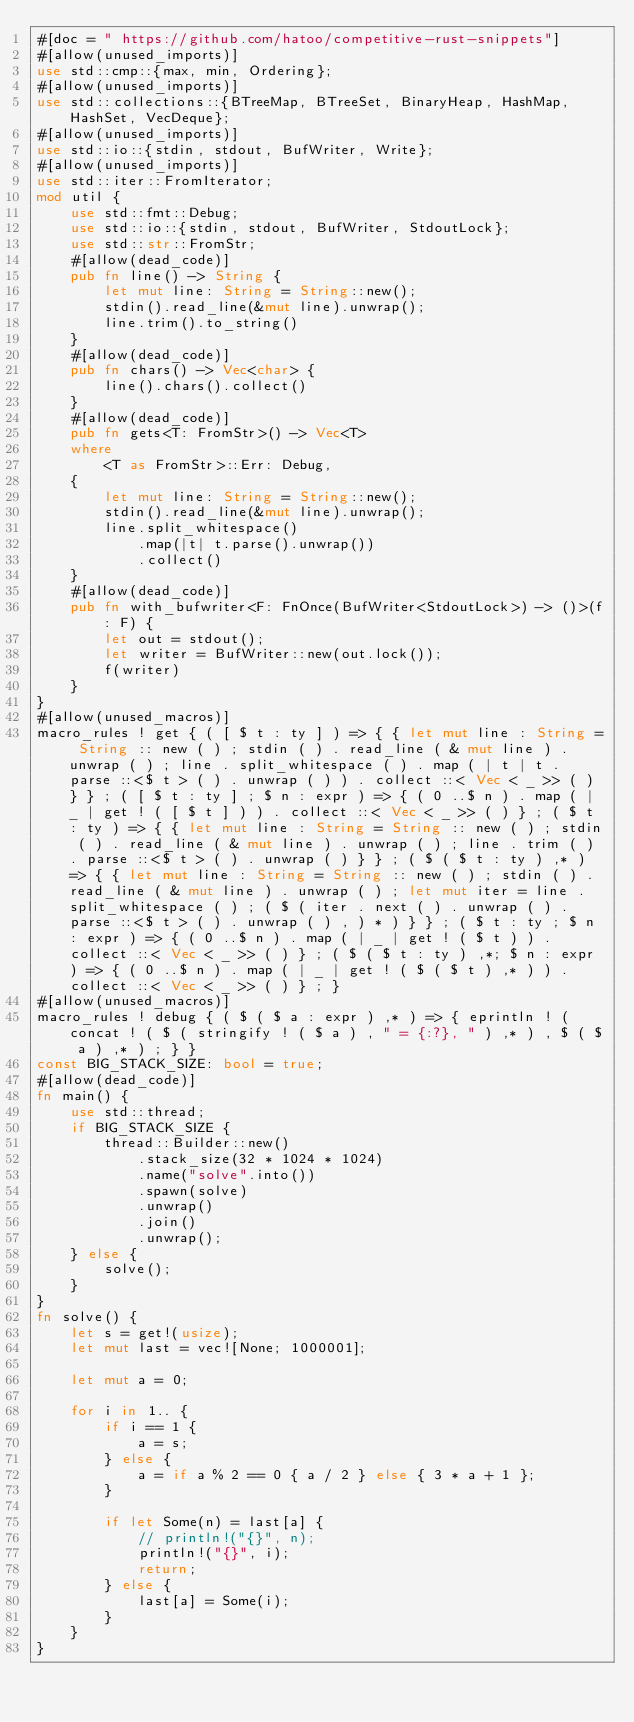<code> <loc_0><loc_0><loc_500><loc_500><_Rust_>#[doc = " https://github.com/hatoo/competitive-rust-snippets"]
#[allow(unused_imports)]
use std::cmp::{max, min, Ordering};
#[allow(unused_imports)]
use std::collections::{BTreeMap, BTreeSet, BinaryHeap, HashMap, HashSet, VecDeque};
#[allow(unused_imports)]
use std::io::{stdin, stdout, BufWriter, Write};
#[allow(unused_imports)]
use std::iter::FromIterator;
mod util {
    use std::fmt::Debug;
    use std::io::{stdin, stdout, BufWriter, StdoutLock};
    use std::str::FromStr;
    #[allow(dead_code)]
    pub fn line() -> String {
        let mut line: String = String::new();
        stdin().read_line(&mut line).unwrap();
        line.trim().to_string()
    }
    #[allow(dead_code)]
    pub fn chars() -> Vec<char> {
        line().chars().collect()
    }
    #[allow(dead_code)]
    pub fn gets<T: FromStr>() -> Vec<T>
    where
        <T as FromStr>::Err: Debug,
    {
        let mut line: String = String::new();
        stdin().read_line(&mut line).unwrap();
        line.split_whitespace()
            .map(|t| t.parse().unwrap())
            .collect()
    }
    #[allow(dead_code)]
    pub fn with_bufwriter<F: FnOnce(BufWriter<StdoutLock>) -> ()>(f: F) {
        let out = stdout();
        let writer = BufWriter::new(out.lock());
        f(writer)
    }
}
#[allow(unused_macros)]
macro_rules ! get { ( [ $ t : ty ] ) => { { let mut line : String = String :: new ( ) ; stdin ( ) . read_line ( & mut line ) . unwrap ( ) ; line . split_whitespace ( ) . map ( | t | t . parse ::<$ t > ( ) . unwrap ( ) ) . collect ::< Vec < _ >> ( ) } } ; ( [ $ t : ty ] ; $ n : expr ) => { ( 0 ..$ n ) . map ( | _ | get ! ( [ $ t ] ) ) . collect ::< Vec < _ >> ( ) } ; ( $ t : ty ) => { { let mut line : String = String :: new ( ) ; stdin ( ) . read_line ( & mut line ) . unwrap ( ) ; line . trim ( ) . parse ::<$ t > ( ) . unwrap ( ) } } ; ( $ ( $ t : ty ) ,* ) => { { let mut line : String = String :: new ( ) ; stdin ( ) . read_line ( & mut line ) . unwrap ( ) ; let mut iter = line . split_whitespace ( ) ; ( $ ( iter . next ( ) . unwrap ( ) . parse ::<$ t > ( ) . unwrap ( ) , ) * ) } } ; ( $ t : ty ; $ n : expr ) => { ( 0 ..$ n ) . map ( | _ | get ! ( $ t ) ) . collect ::< Vec < _ >> ( ) } ; ( $ ( $ t : ty ) ,*; $ n : expr ) => { ( 0 ..$ n ) . map ( | _ | get ! ( $ ( $ t ) ,* ) ) . collect ::< Vec < _ >> ( ) } ; }
#[allow(unused_macros)]
macro_rules ! debug { ( $ ( $ a : expr ) ,* ) => { eprintln ! ( concat ! ( $ ( stringify ! ( $ a ) , " = {:?}, " ) ,* ) , $ ( $ a ) ,* ) ; } }
const BIG_STACK_SIZE: bool = true;
#[allow(dead_code)]
fn main() {
    use std::thread;
    if BIG_STACK_SIZE {
        thread::Builder::new()
            .stack_size(32 * 1024 * 1024)
            .name("solve".into())
            .spawn(solve)
            .unwrap()
            .join()
            .unwrap();
    } else {
        solve();
    }
}
fn solve() {
    let s = get!(usize);
    let mut last = vec![None; 1000001];

    let mut a = 0;

    for i in 1.. {
        if i == 1 {
            a = s;
        } else {
            a = if a % 2 == 0 { a / 2 } else { 3 * a + 1 };
        }

        if let Some(n) = last[a] {
            // println!("{}", n);
            println!("{}", i);
            return;
        } else {
            last[a] = Some(i);
        }
    }
}
</code> 